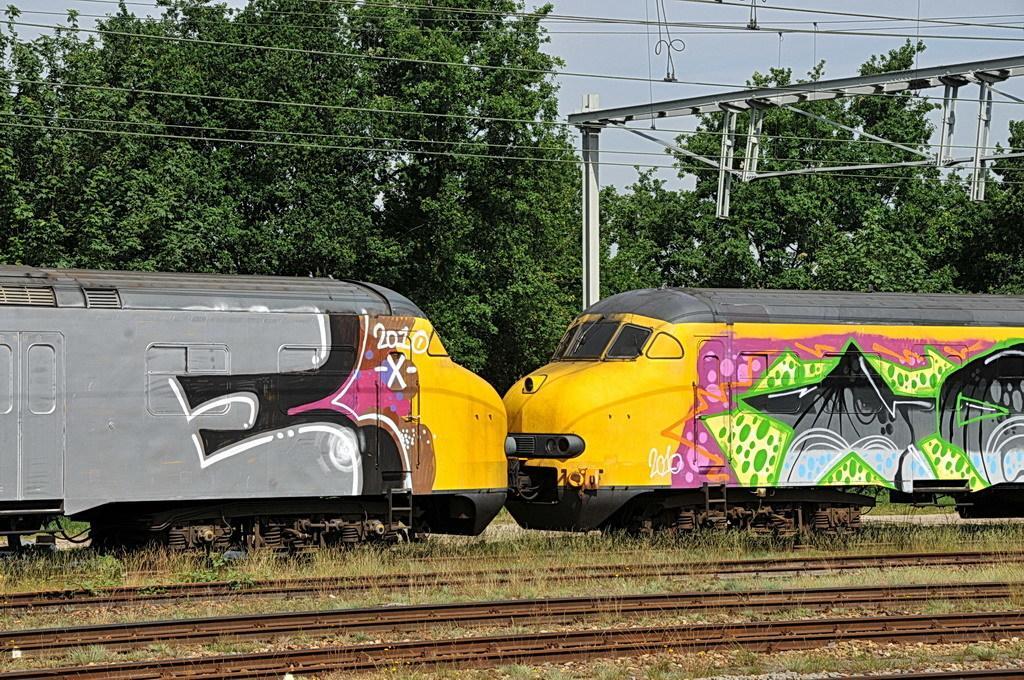How would you summarize this image in a sentence or two? In this image we can see two trains are on the railway tracks. Background of the image trees are present. Right top of the image electric wires and pole is present. 